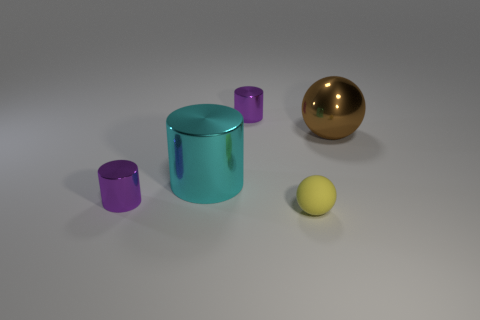There is a big thing that is in front of the large brown thing; is there a small purple thing in front of it?
Keep it short and to the point. Yes. Are there any other things that are made of the same material as the cyan cylinder?
Offer a very short reply. Yes. Does the cyan metallic thing have the same shape as the purple thing that is in front of the big cyan cylinder?
Your answer should be compact. Yes. What number of other things are the same size as the brown thing?
Provide a short and direct response. 1. How many cyan things are small matte objects or cylinders?
Offer a terse response. 1. What number of metal cylinders are both left of the large cylinder and behind the large brown metallic thing?
Your response must be concise. 0. There is a tiny cylinder left of the big object that is on the left side of the small yellow object in front of the cyan cylinder; what is its material?
Your answer should be compact. Metal. What number of other yellow spheres are made of the same material as the large sphere?
Ensure brevity in your answer.  0. The cyan object that is the same size as the shiny ball is what shape?
Make the answer very short. Cylinder. Are there any metallic cylinders in front of the yellow sphere?
Offer a very short reply. No. 